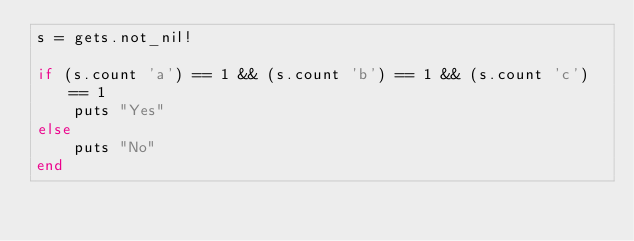<code> <loc_0><loc_0><loc_500><loc_500><_Crystal_>s = gets.not_nil!

if (s.count 'a') == 1 && (s.count 'b') == 1 && (s.count 'c') == 1
    puts "Yes"
else
    puts "No"
end
</code> 